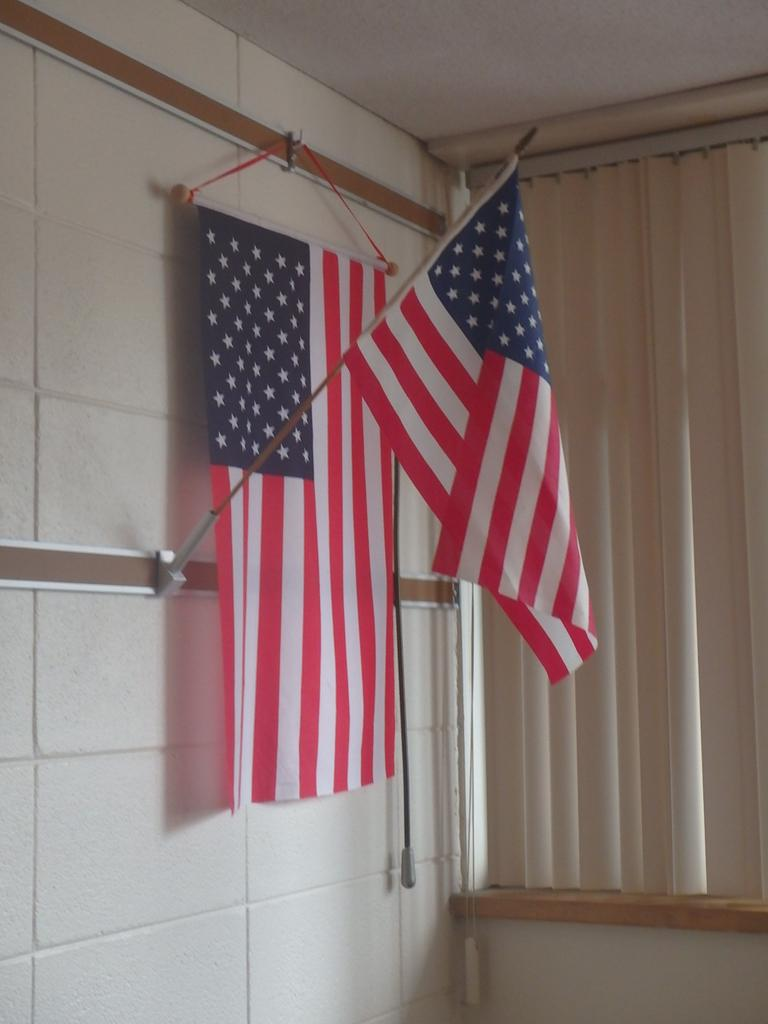What can be seen flying or waving in the image? There are flags in the image. What type of structure is present in the image? There is a wall in the image. What else is visible in the image besides the flags and wall? There are objects in the image. What can be seen in the background of the image? There is a roof and a curtain visible in the background of the image. How does the hen interact with the flags in the image? There is no hen present in the image, so it cannot interact with the flags. 